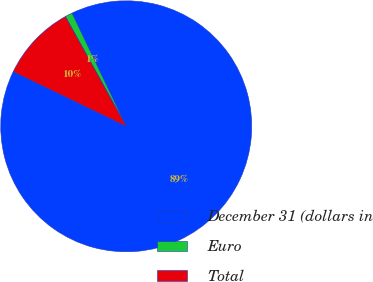<chart> <loc_0><loc_0><loc_500><loc_500><pie_chart><fcel>December 31 (dollars in<fcel>Euro<fcel>Total<nl><fcel>89.28%<fcel>0.94%<fcel>9.78%<nl></chart> 